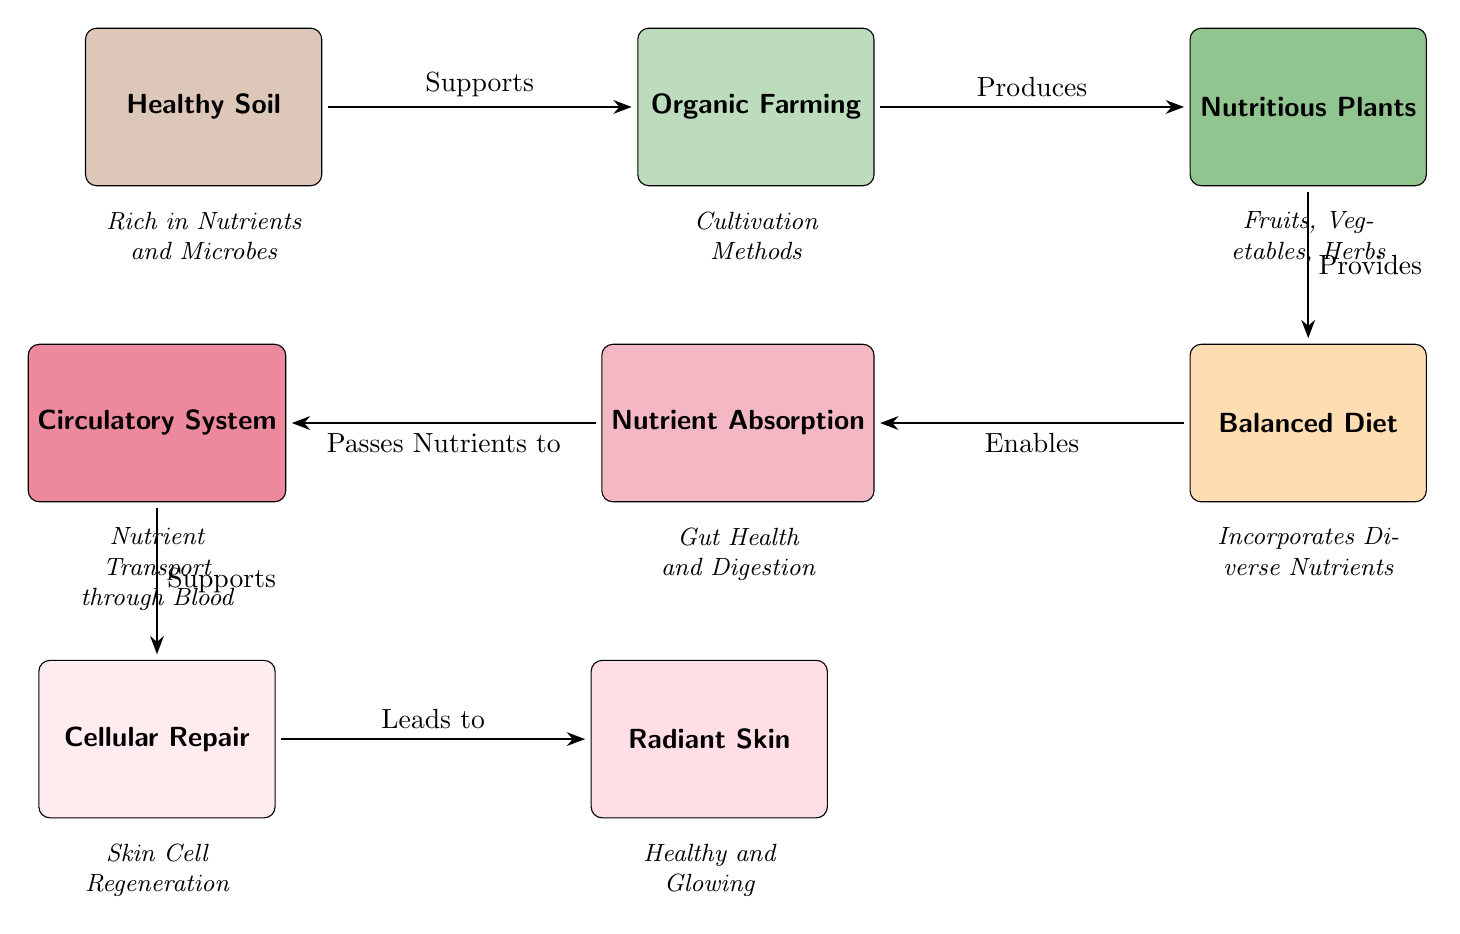What is the starting point of the nutrient journey? The diagram shows that the journey of nutrients begins at the "Healthy Soil" node, indicating its foundational role in the process.
Answer: Healthy Soil What contributes to the cultivation of nutritious plants? According to the diagram, "Organic Farming" is positioned as producing the "Nutritious Plants," establishing a direct connection between farming methods and plant nutrition.
Answer: Organic Farming How many nodes represent the skin health aspects in the diagram? The diagram includes two nodes specifically related to skin health: "Cellular Repair" and "Radiant Skin." Counting these gives a total of two nodes for skin health.
Answer: 2 What enables nutrient absorption in the body? The diagram states that a "Balanced Diet" enables nutrient absorption, highlighting its crucial role in the process before nutrients are absorbed.
Answer: Balanced Diet Which node supports both the circulatory system and skin health? The "Circulatory System" node is positioned as passing nutrients to "Cellular Repair," which subsequently leads to "Radiant Skin," establishing its supportive role in overall skin health.
Answer: Circulatory System What relationship is indicated between nutrient absorption and the circulatory system? The diagram specifies that nutrient absorption directly passes nutrients to the circulatory system, demonstrating a sequential step in the nutrient journey from diet to body systems.
Answer: Passes Nutrients to What kind of plants are cultivated through organic farming? The "Nutritious Plants" node specifies that these include "Fruits, Vegetables, Herbs," indicating the types of plants that result from the organic farming practices described in the diagram.
Answer: Fruits, Vegetables, Herbs Which node is directly linked to the quality of the skin? The diagram illustrates that "Radiant Skin" is the final outcome of the nutrient journey, directly linked to the preceding nodes that process and repair skin cells.
Answer: Radiant Skin What is the importance of healthy soil in the food chain? "Healthy Soil" is essential as it supports organic farming, which leads to nutritious plants, emphasizing its critical role at the beginning of the nutrient journey.
Answer: Supports How does nutrient absorption impact skin health? Nutrient absorption is linked to "Cellular Repair," which subsequently leads to "Radiant Skin," emphasizing its importance as a necessary step for maintaining healthy skin.
Answer: Necessary Step 